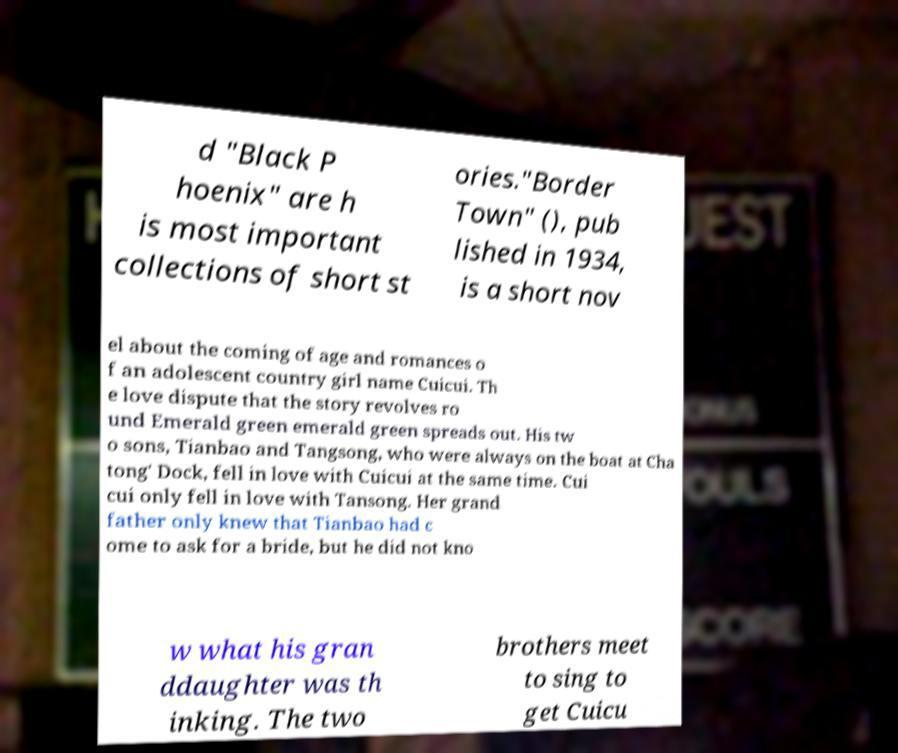Could you assist in decoding the text presented in this image and type it out clearly? d "Black P hoenix" are h is most important collections of short st ories."Border Town" (), pub lished in 1934, is a short nov el about the coming of age and romances o f an adolescent country girl name Cuicui. Th e love dispute that the story revolves ro und Emerald green emerald green spreads out. His tw o sons, Tianbao and Tangsong, who were always on the boat at Cha tong' Dock, fell in love with Cuicui at the same time. Cui cui only fell in love with Tansong. Her grand father only knew that Tianbao had c ome to ask for a bride, but he did not kno w what his gran ddaughter was th inking. The two brothers meet to sing to get Cuicu 